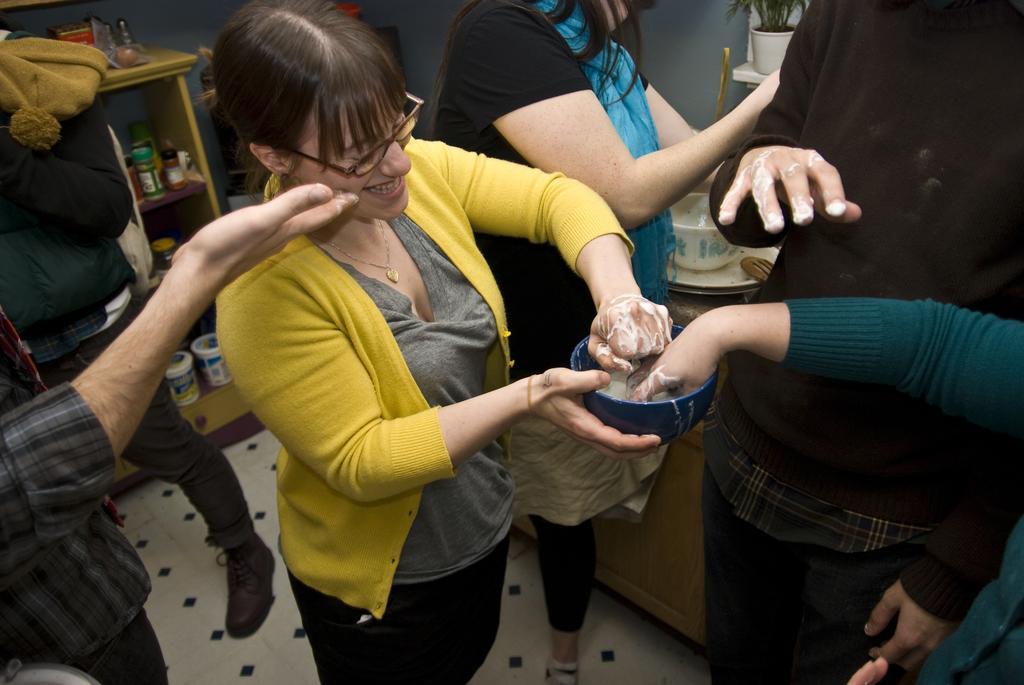Could you give a brief overview of what you see in this image? In this image there are a few people standing. The woman in the center is holding a bowl in her hand. They are dropping their hands in the bowl. Behind them there are bowls and plates on the table. At the top there is a houseplant. To the left there is a wooden cupboard. There are boxes and bottles in the cupboard. 